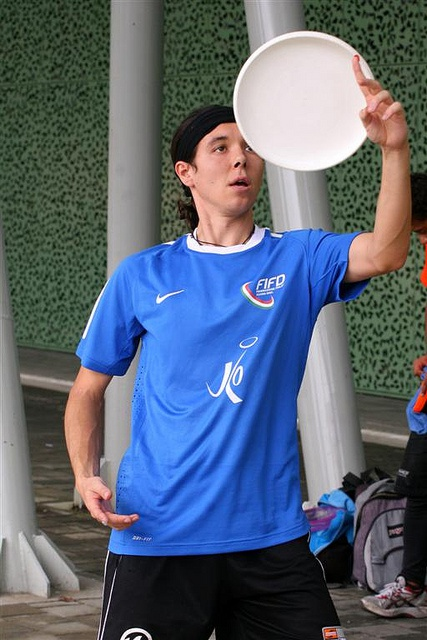Describe the objects in this image and their specific colors. I can see people in darkgreen, black, blue, and lightblue tones, frisbee in darkgreen, lightgray, and darkgray tones, people in darkgreen, black, gray, maroon, and brown tones, backpack in darkgreen, black, navy, blue, and gray tones, and backpack in darkgreen, gray, black, and darkgray tones in this image. 